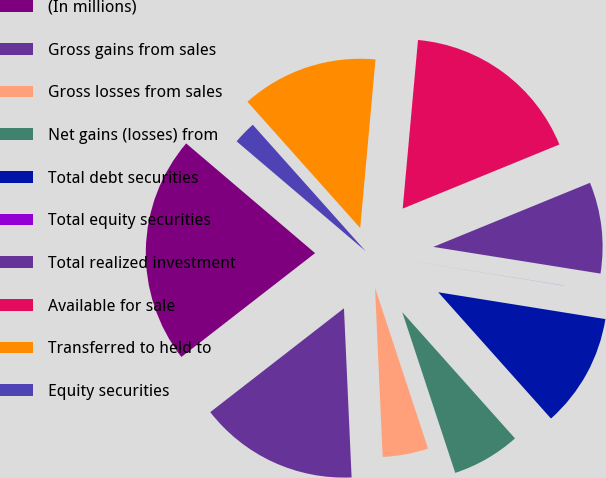Convert chart. <chart><loc_0><loc_0><loc_500><loc_500><pie_chart><fcel>(In millions)<fcel>Gross gains from sales<fcel>Gross losses from sales<fcel>Net gains (losses) from<fcel>Total debt securities<fcel>Total equity securities<fcel>Total realized investment<fcel>Available for sale<fcel>Transferred to held to<fcel>Equity securities<nl><fcel>21.73%<fcel>15.21%<fcel>4.35%<fcel>6.53%<fcel>10.87%<fcel>0.01%<fcel>8.7%<fcel>17.38%<fcel>13.04%<fcel>2.18%<nl></chart> 